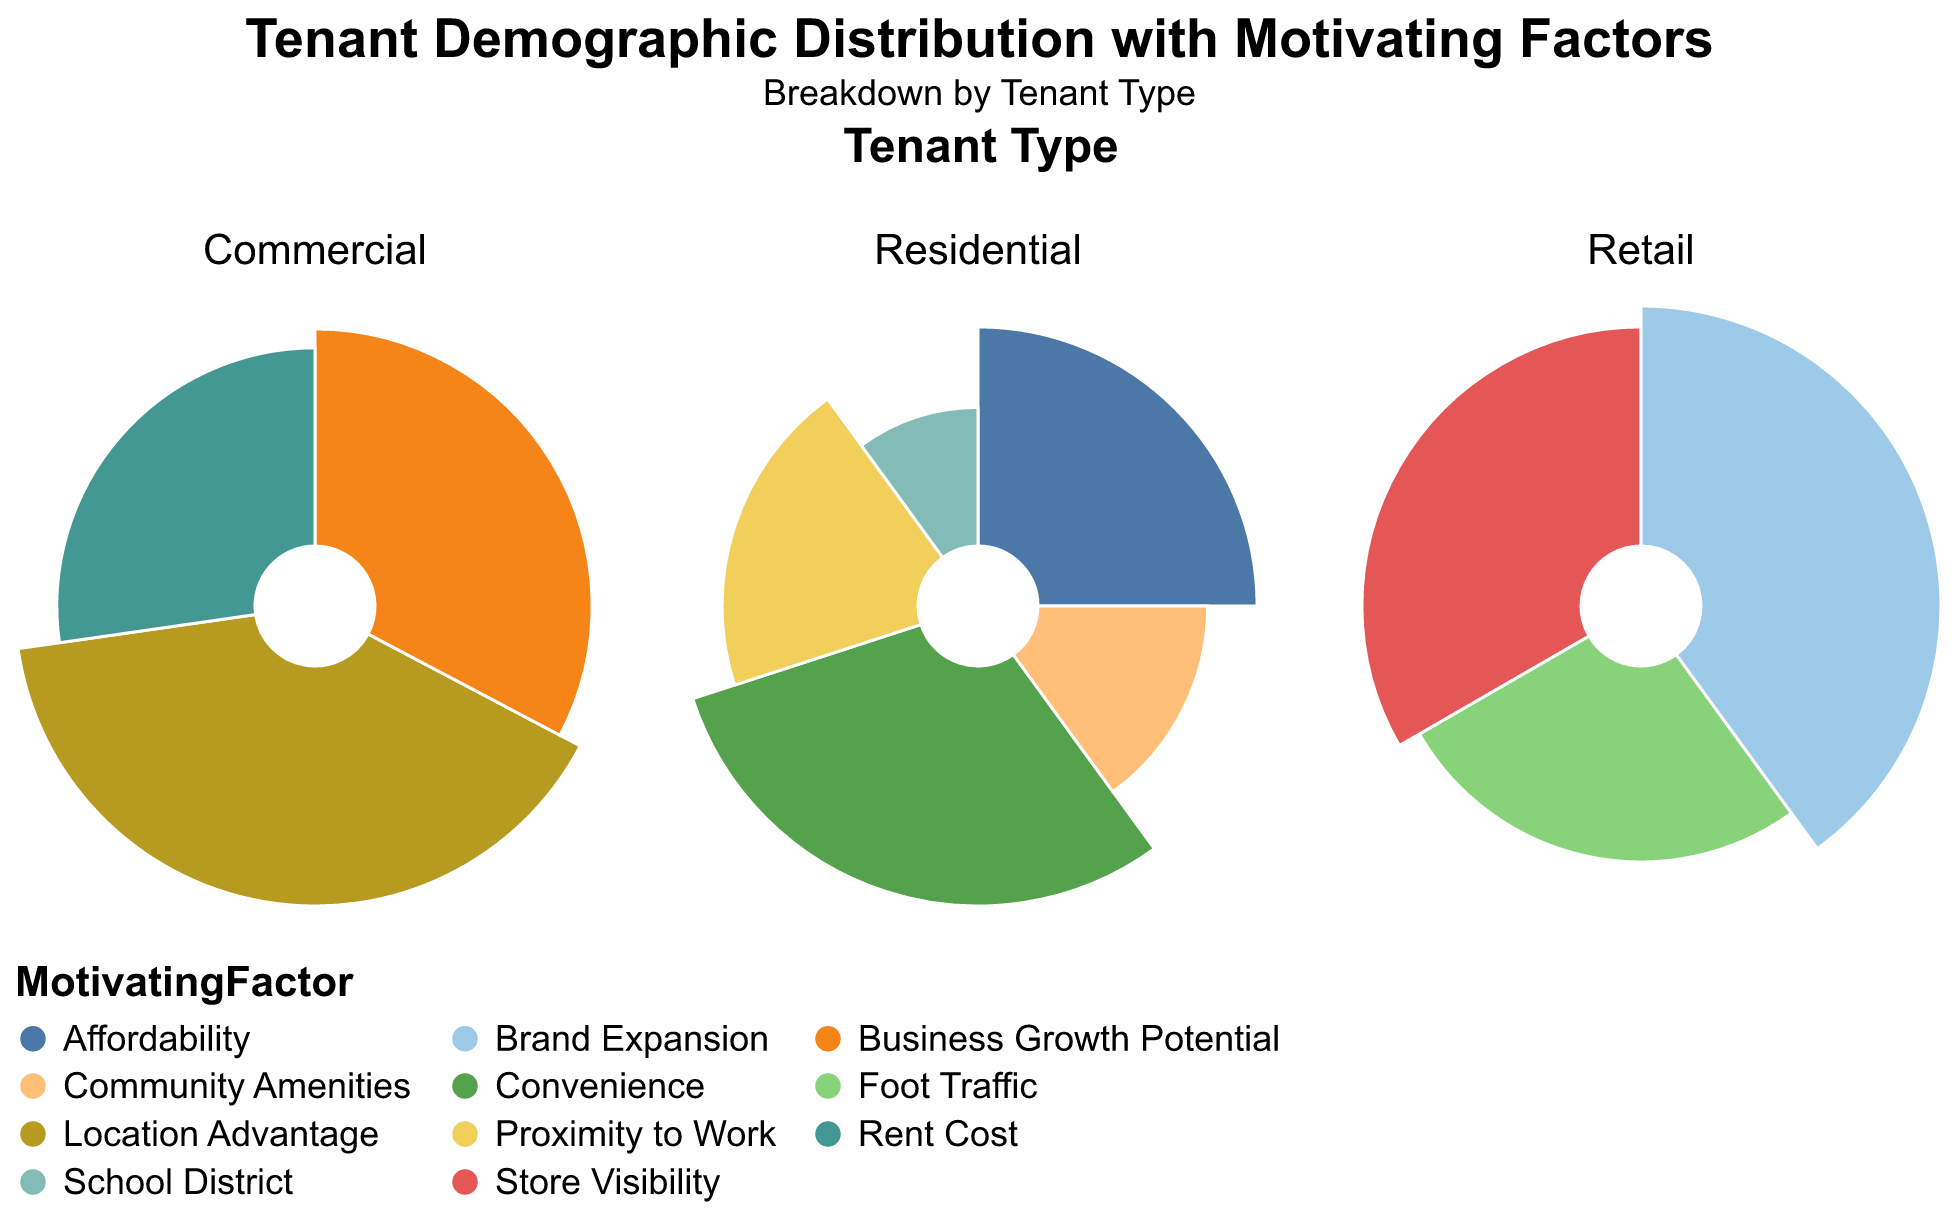What are the three tenant types shown in the title of the figure? The figure's title states "Breakdown by Tenant Type," where the subtitles mention three tenant types: Residential, Commercial, and Retail.
Answer: Residential, Commercial, and Retail Which motivating factor has the highest percentage for Residential tenants aged 18-24? Residential tenants aged 18-24 have two motivating factors: Convenience at 30% and Affordability at 25%. The highest percentage is for Convenience.
Answer: Convenience How do the percentages for the "Foot Traffic" factor compare between Retail and Commercial tenants? The "Foot Traffic" factor is only present in the Retail category for tenants aged 25-34, with a percentage of 20%. There is no "Foot Traffic" factor listed for Commercial tenants.
Answer: Retail: 20%, Commercial: 0% Which age group in the Residential tenant type has the least representation by percentage, and what is its motivating factor? The Residential tenant type's age group 35-44 has the smallest percentage at 10%, with the motivating factor being School District.
Answer: 35-44, School District What is the total percentage of Retail tenants motivated by "Brand Expansion" and "Store Visibility"? Retail tenants are motivated by Brand Expansion at 30% and Store Visibility at 25%. Adding these percentages results in 30% + 25% = 55%.
Answer: 55% What motivating factor drives the highest percentage of tenants among all Commercial tenants, and what is that percentage? Commercial tenants have three motivating factors: Location Advantage at 22%, Business Growth Potential at 18%, and Rent Cost at 15%. Location Advantage has the highest percentage at 22%.
Answer: Location Advantage, 22% Compare the motivating factors for Residential tenants aged 25-34 with a medium income level and a high income level. Residential tenants aged 25-34 and medium income are motivated by Proximity to Work at 20%, while those with high income are motivated by Community Amenities at 15%. Proximity to Work (20%) is higher than Community Amenities (15%).
Answer: Medium Income: Proximity to Work (20%), High Income: Community Amenities (15%) Which factor stands out as unique to the Commercial category and does not appear in the other tenant types? Business Growth Potential is a motivating factor unique to the Commercial category; it is not present in the Residential or Retail categories.
Answer: Business Growth Potential 